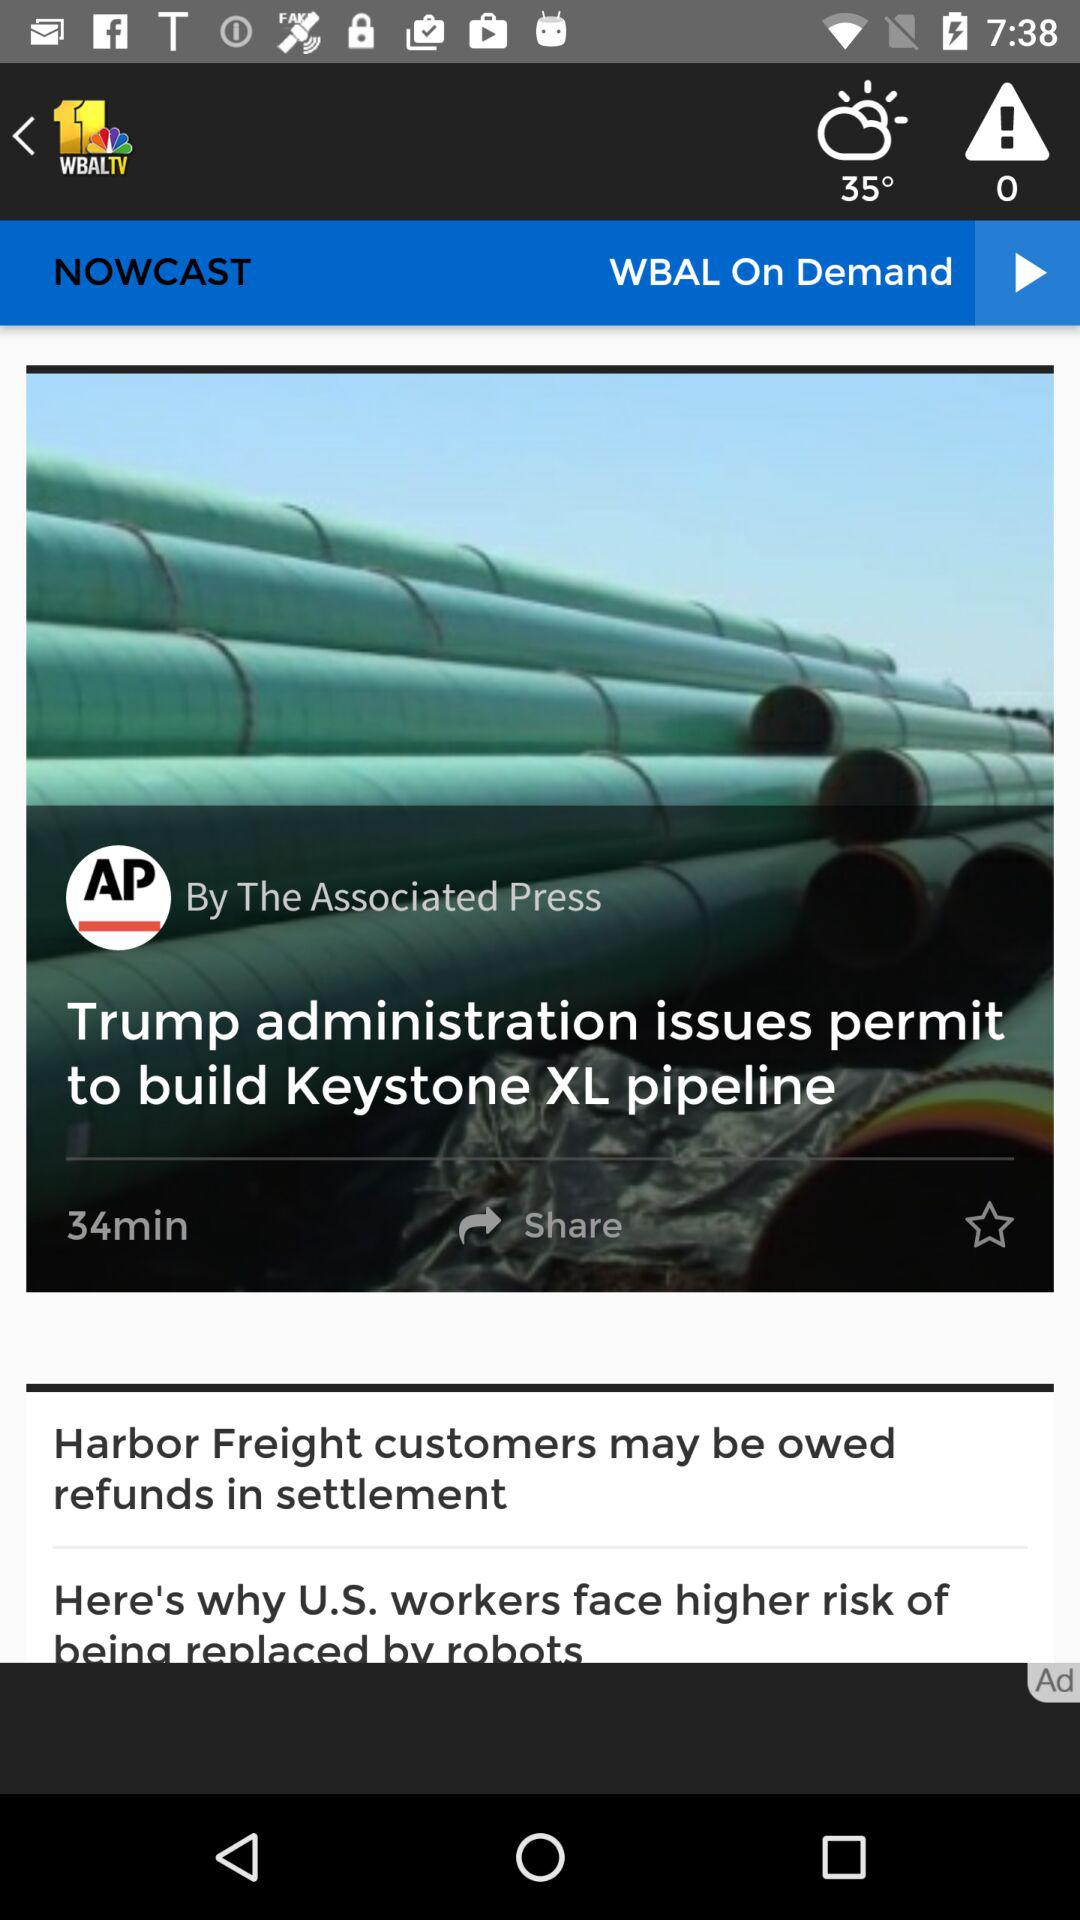What is the given duration? The given duration is 34 minutes. 